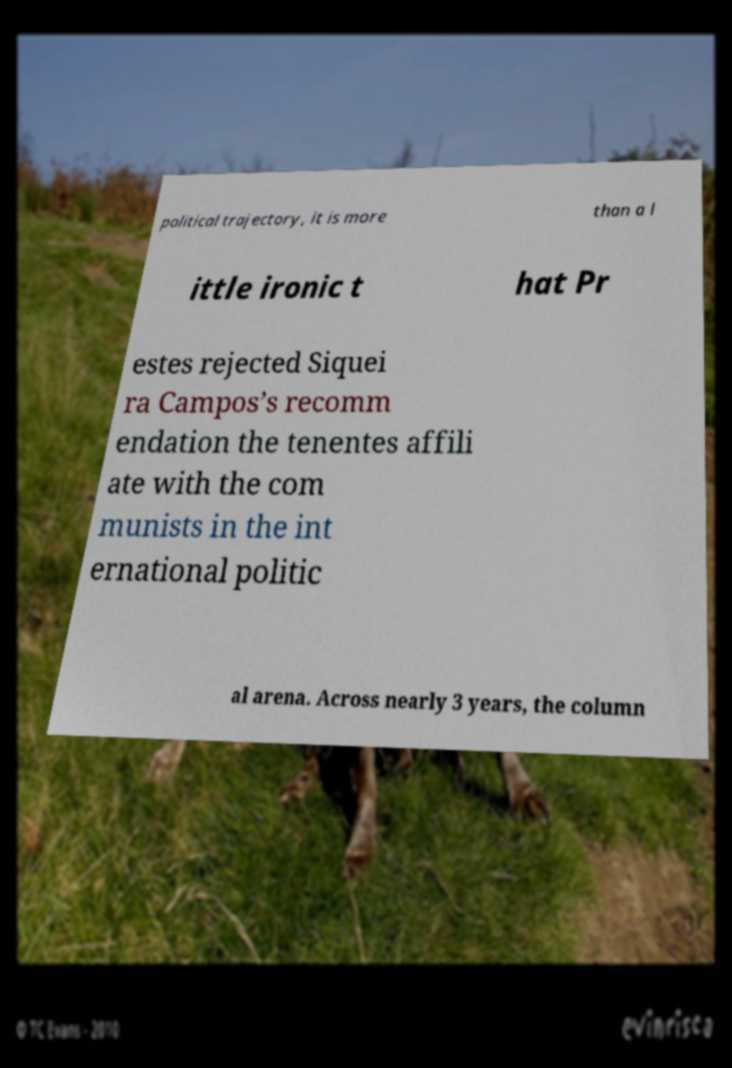Please read and relay the text visible in this image. What does it say? political trajectory, it is more than a l ittle ironic t hat Pr estes rejected Siquei ra Campos’s recomm endation the tenentes affili ate with the com munists in the int ernational politic al arena. Across nearly 3 years, the column 